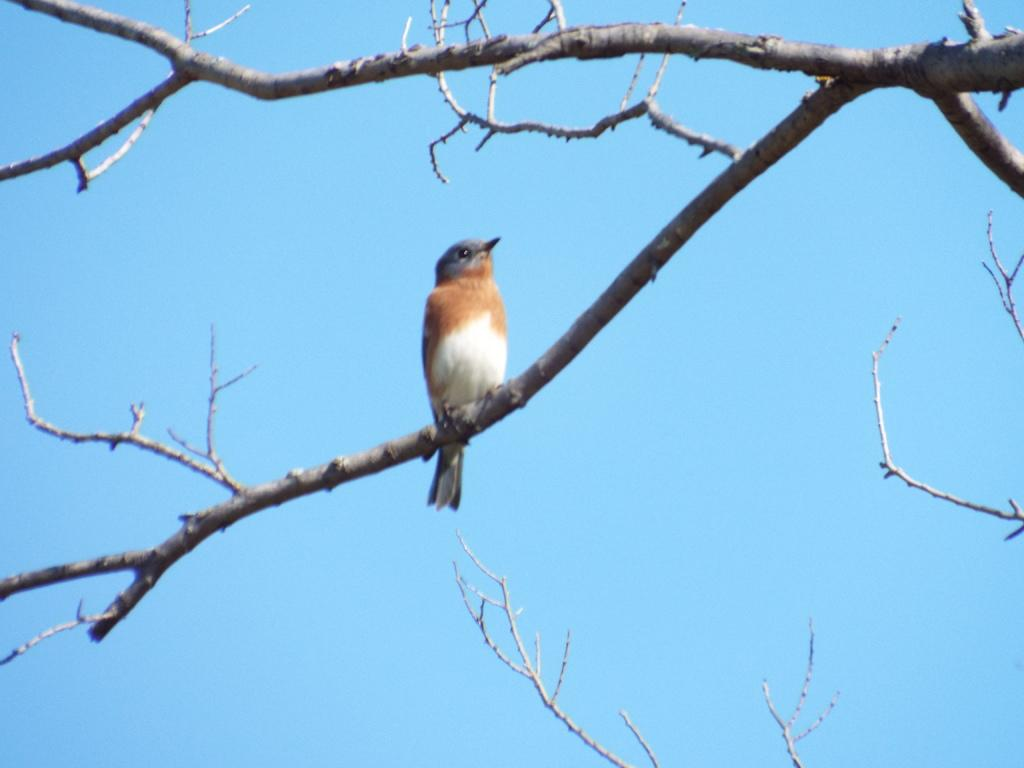What type of animal can be seen in the image? There is a bird in the image. Where is the bird located? The bird is sitting on a dried tree. What colors can be observed on the bird? The bird has white and brown colors. What is the color of the sky in the background? The sky in the background is blue. What month is the bird's attraction happening in the image? There is no indication of a bird's attraction or a specific month in the image. 